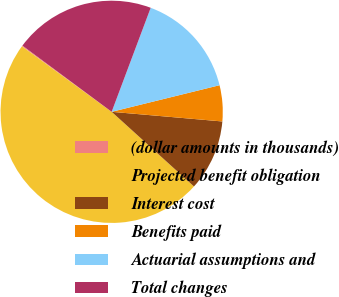Convert chart to OTSL. <chart><loc_0><loc_0><loc_500><loc_500><pie_chart><fcel>(dollar amounts in thousands)<fcel>Projected benefit obligation<fcel>Interest cost<fcel>Benefits paid<fcel>Actuarial assumptions and<fcel>Total changes<nl><fcel>0.13%<fcel>48.31%<fcel>10.34%<fcel>5.23%<fcel>15.44%<fcel>20.55%<nl></chart> 